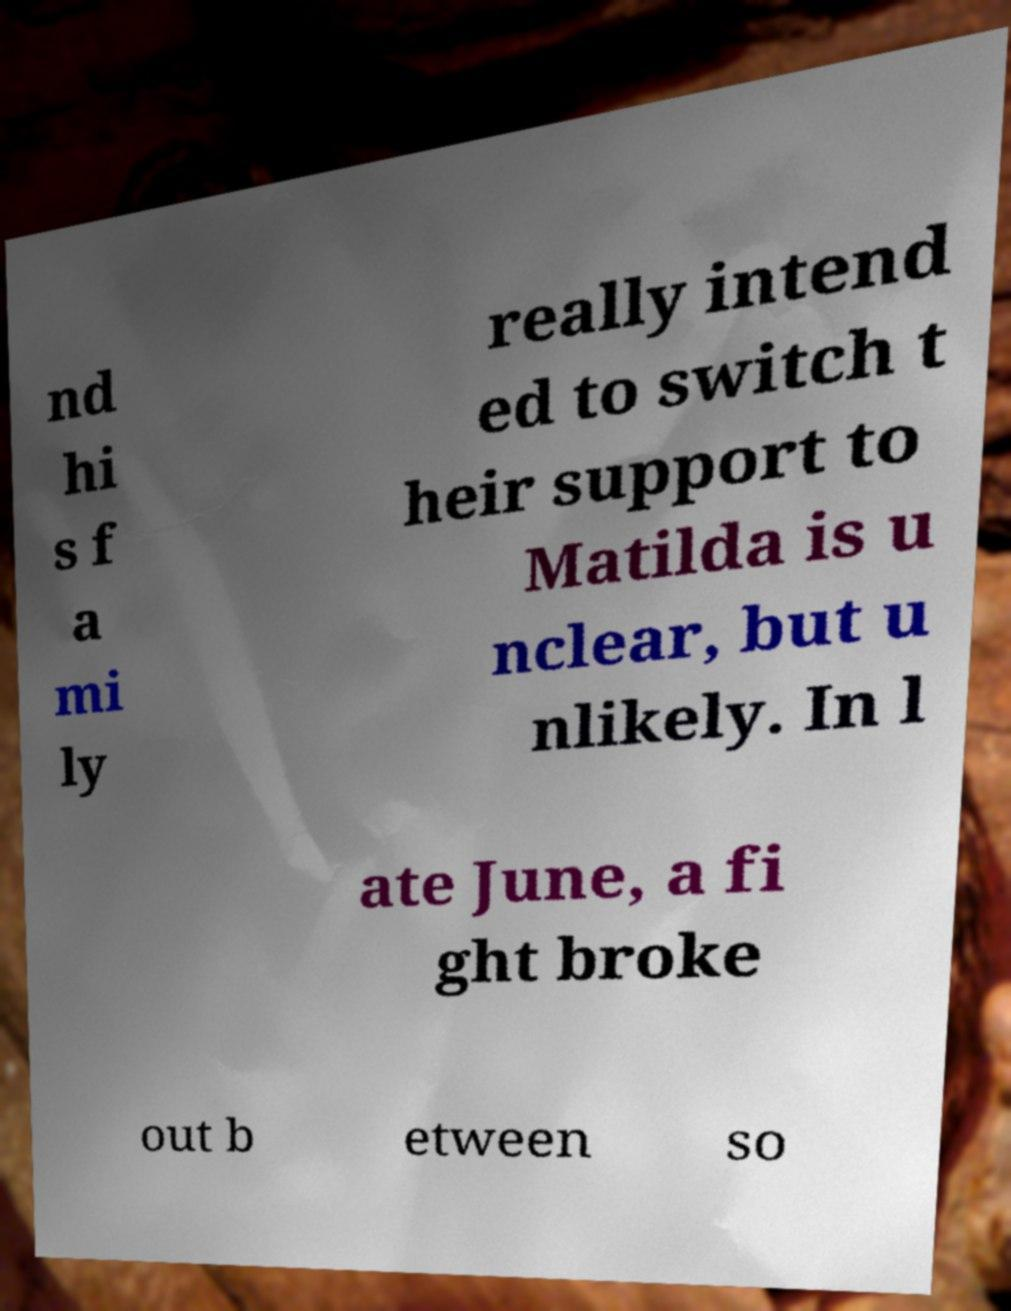I need the written content from this picture converted into text. Can you do that? nd hi s f a mi ly really intend ed to switch t heir support to Matilda is u nclear, but u nlikely. In l ate June, a fi ght broke out b etween so 